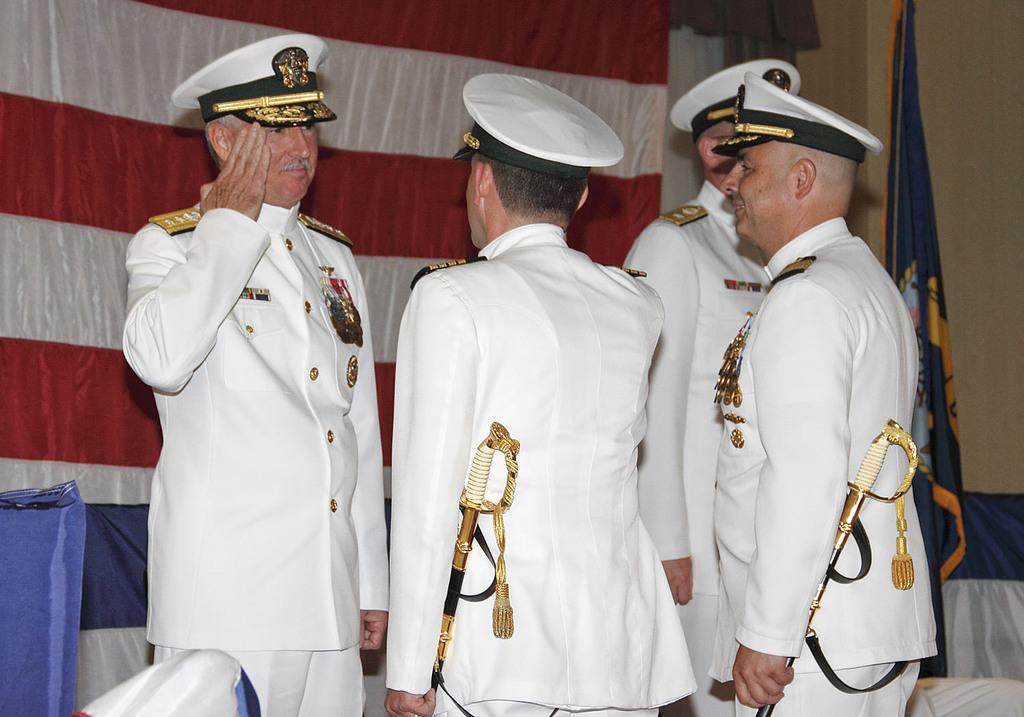What is happening in the image? There is a group of people standing in the image. What can be seen on the backside of the image? There are flags visible on the backside of the image. What is visible in the background of the image? There is a wall in the background of the image. What type of slope can be seen in the image? There is no slope present in the image; it features a group of people standing and flags in the background. 